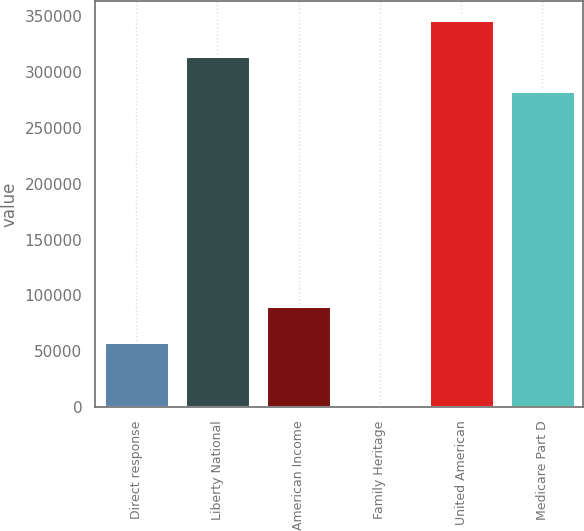Convert chart. <chart><loc_0><loc_0><loc_500><loc_500><bar_chart><fcel>Direct response<fcel>Liberty National<fcel>American Income<fcel>Family Heritage<fcel>United American<fcel>Medicare Part D<nl><fcel>58512<fcel>314757<fcel>90281.7<fcel>2.12<fcel>346526<fcel>282987<nl></chart> 